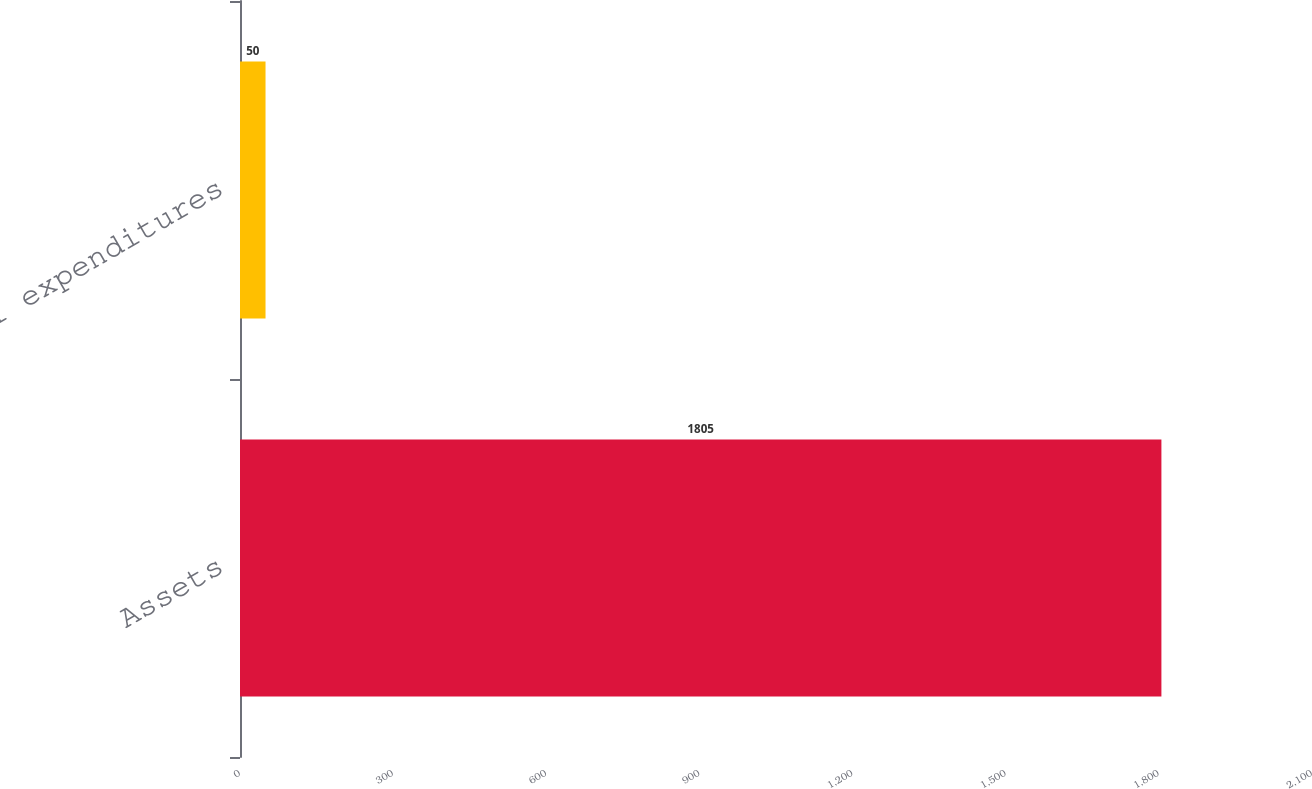Convert chart. <chart><loc_0><loc_0><loc_500><loc_500><bar_chart><fcel>Assets<fcel>Capital expenditures<nl><fcel>1805<fcel>50<nl></chart> 